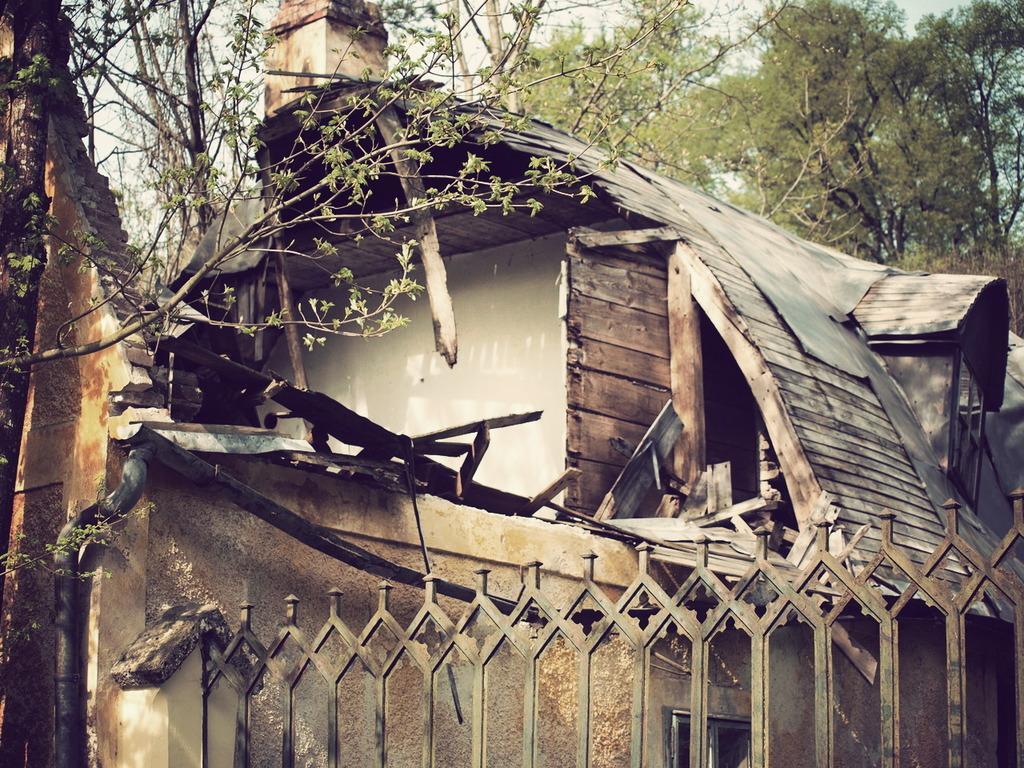In one or two sentences, can you explain what this image depicts? There is a wooden house and in front of the house there is a tall tree,it is partially dried up and behind the house there are some other trees. 